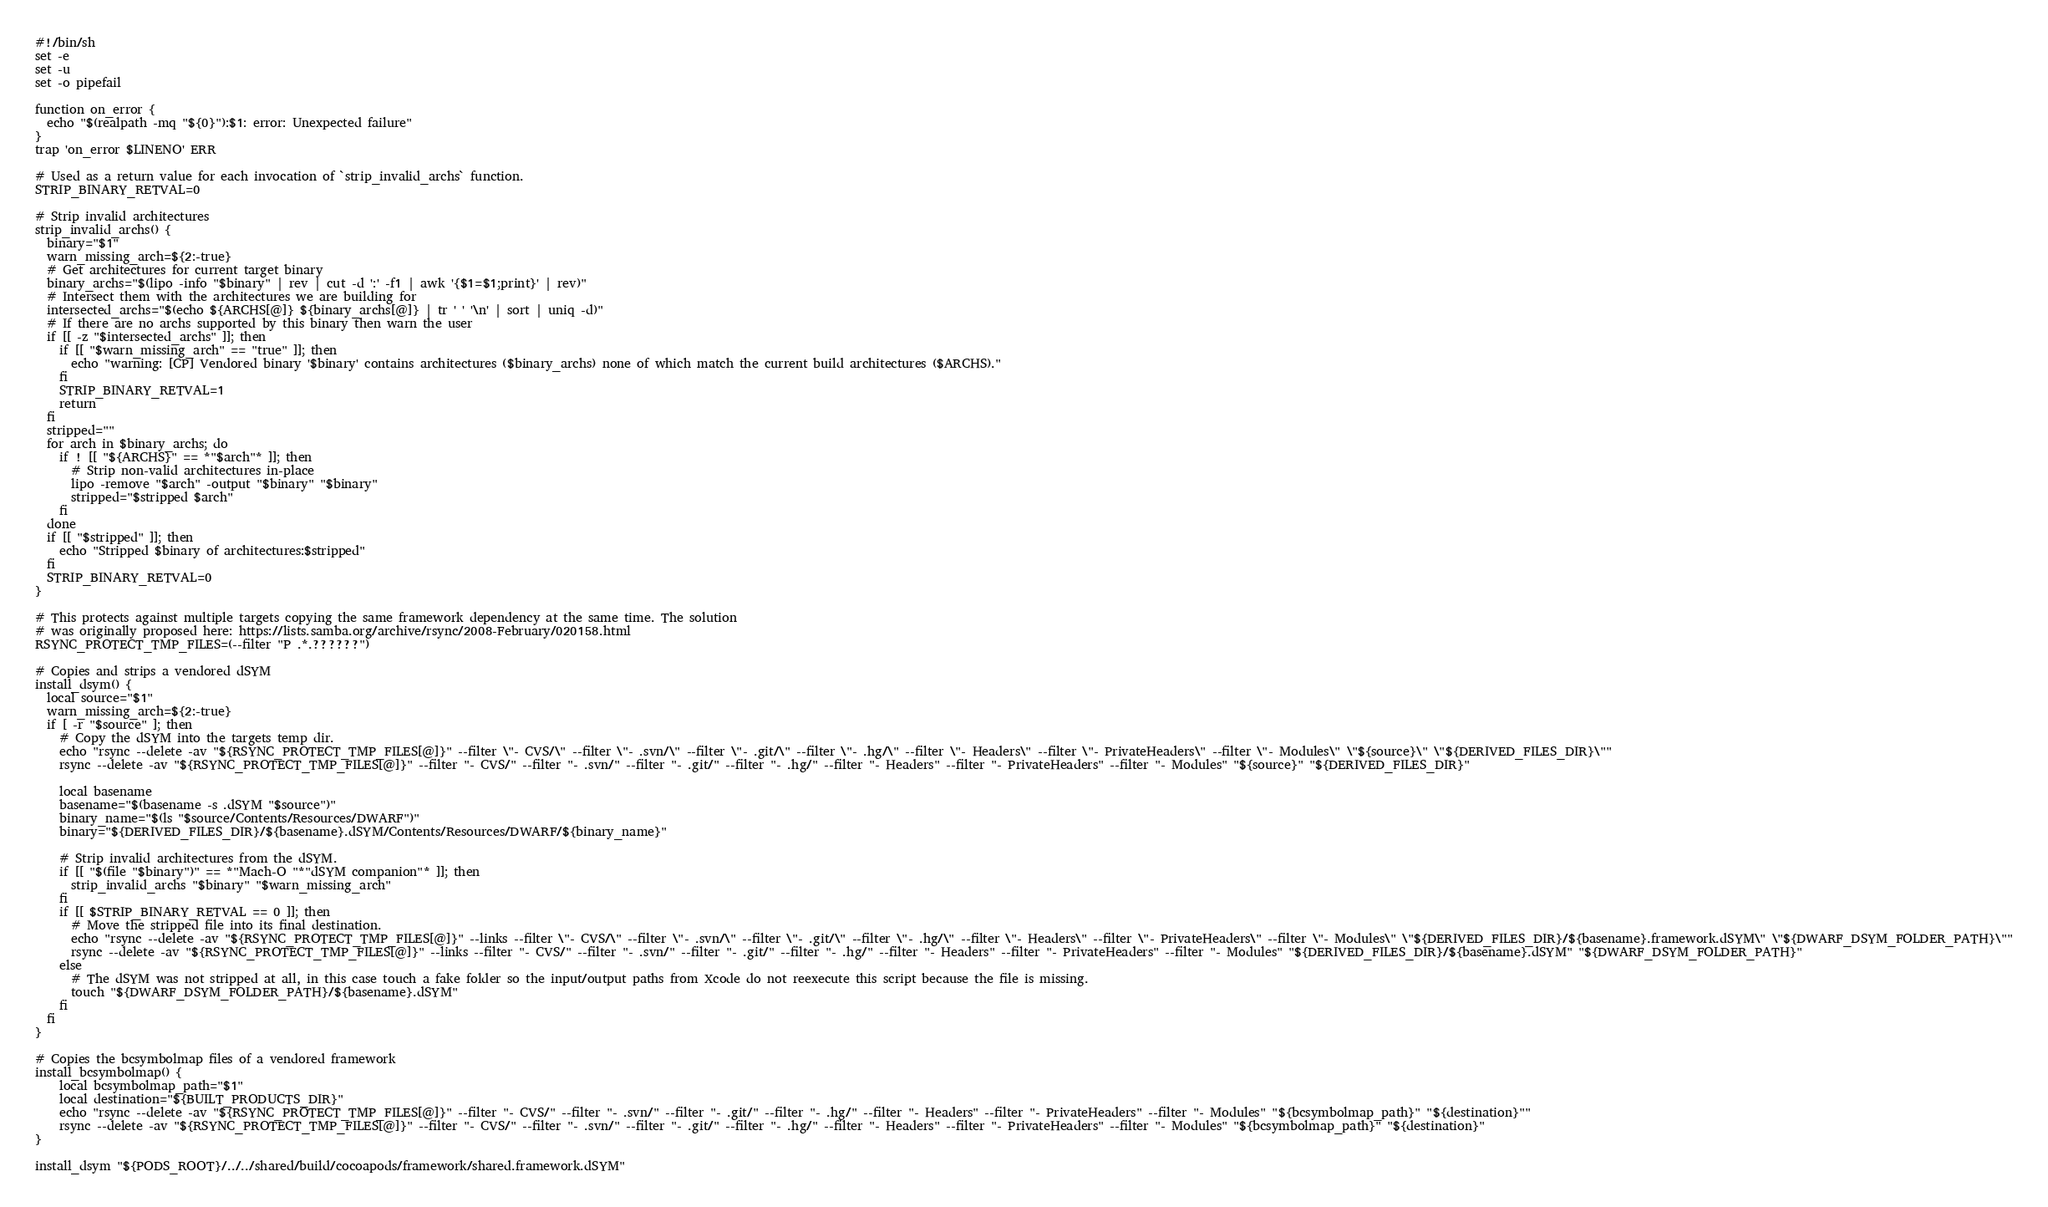<code> <loc_0><loc_0><loc_500><loc_500><_Bash_>#!/bin/sh
set -e
set -u
set -o pipefail

function on_error {
  echo "$(realpath -mq "${0}"):$1: error: Unexpected failure"
}
trap 'on_error $LINENO' ERR

# Used as a return value for each invocation of `strip_invalid_archs` function.
STRIP_BINARY_RETVAL=0

# Strip invalid architectures
strip_invalid_archs() {
  binary="$1"
  warn_missing_arch=${2:-true}
  # Get architectures for current target binary
  binary_archs="$(lipo -info "$binary" | rev | cut -d ':' -f1 | awk '{$1=$1;print}' | rev)"
  # Intersect them with the architectures we are building for
  intersected_archs="$(echo ${ARCHS[@]} ${binary_archs[@]} | tr ' ' '\n' | sort | uniq -d)"
  # If there are no archs supported by this binary then warn the user
  if [[ -z "$intersected_archs" ]]; then
    if [[ "$warn_missing_arch" == "true" ]]; then
      echo "warning: [CP] Vendored binary '$binary' contains architectures ($binary_archs) none of which match the current build architectures ($ARCHS)."
    fi
    STRIP_BINARY_RETVAL=1
    return
  fi
  stripped=""
  for arch in $binary_archs; do
    if ! [[ "${ARCHS}" == *"$arch"* ]]; then
      # Strip non-valid architectures in-place
      lipo -remove "$arch" -output "$binary" "$binary"
      stripped="$stripped $arch"
    fi
  done
  if [[ "$stripped" ]]; then
    echo "Stripped $binary of architectures:$stripped"
  fi
  STRIP_BINARY_RETVAL=0
}

# This protects against multiple targets copying the same framework dependency at the same time. The solution
# was originally proposed here: https://lists.samba.org/archive/rsync/2008-February/020158.html
RSYNC_PROTECT_TMP_FILES=(--filter "P .*.??????")

# Copies and strips a vendored dSYM
install_dsym() {
  local source="$1"
  warn_missing_arch=${2:-true}
  if [ -r "$source" ]; then
    # Copy the dSYM into the targets temp dir.
    echo "rsync --delete -av "${RSYNC_PROTECT_TMP_FILES[@]}" --filter \"- CVS/\" --filter \"- .svn/\" --filter \"- .git/\" --filter \"- .hg/\" --filter \"- Headers\" --filter \"- PrivateHeaders\" --filter \"- Modules\" \"${source}\" \"${DERIVED_FILES_DIR}\""
    rsync --delete -av "${RSYNC_PROTECT_TMP_FILES[@]}" --filter "- CVS/" --filter "- .svn/" --filter "- .git/" --filter "- .hg/" --filter "- Headers" --filter "- PrivateHeaders" --filter "- Modules" "${source}" "${DERIVED_FILES_DIR}"

    local basename
    basename="$(basename -s .dSYM "$source")"
    binary_name="$(ls "$source/Contents/Resources/DWARF")"
    binary="${DERIVED_FILES_DIR}/${basename}.dSYM/Contents/Resources/DWARF/${binary_name}"

    # Strip invalid architectures from the dSYM.
    if [[ "$(file "$binary")" == *"Mach-O "*"dSYM companion"* ]]; then
      strip_invalid_archs "$binary" "$warn_missing_arch"
    fi
    if [[ $STRIP_BINARY_RETVAL == 0 ]]; then
      # Move the stripped file into its final destination.
      echo "rsync --delete -av "${RSYNC_PROTECT_TMP_FILES[@]}" --links --filter \"- CVS/\" --filter \"- .svn/\" --filter \"- .git/\" --filter \"- .hg/\" --filter \"- Headers\" --filter \"- PrivateHeaders\" --filter \"- Modules\" \"${DERIVED_FILES_DIR}/${basename}.framework.dSYM\" \"${DWARF_DSYM_FOLDER_PATH}\""
      rsync --delete -av "${RSYNC_PROTECT_TMP_FILES[@]}" --links --filter "- CVS/" --filter "- .svn/" --filter "- .git/" --filter "- .hg/" --filter "- Headers" --filter "- PrivateHeaders" --filter "- Modules" "${DERIVED_FILES_DIR}/${basename}.dSYM" "${DWARF_DSYM_FOLDER_PATH}"
    else
      # The dSYM was not stripped at all, in this case touch a fake folder so the input/output paths from Xcode do not reexecute this script because the file is missing.
      touch "${DWARF_DSYM_FOLDER_PATH}/${basename}.dSYM"
    fi
  fi
}

# Copies the bcsymbolmap files of a vendored framework
install_bcsymbolmap() {
    local bcsymbolmap_path="$1"
    local destination="${BUILT_PRODUCTS_DIR}"
    echo "rsync --delete -av "${RSYNC_PROTECT_TMP_FILES[@]}" --filter "- CVS/" --filter "- .svn/" --filter "- .git/" --filter "- .hg/" --filter "- Headers" --filter "- PrivateHeaders" --filter "- Modules" "${bcsymbolmap_path}" "${destination}""
    rsync --delete -av "${RSYNC_PROTECT_TMP_FILES[@]}" --filter "- CVS/" --filter "- .svn/" --filter "- .git/" --filter "- .hg/" --filter "- Headers" --filter "- PrivateHeaders" --filter "- Modules" "${bcsymbolmap_path}" "${destination}"
}

install_dsym "${PODS_ROOT}/../../shared/build/cocoapods/framework/shared.framework.dSYM"
</code> 